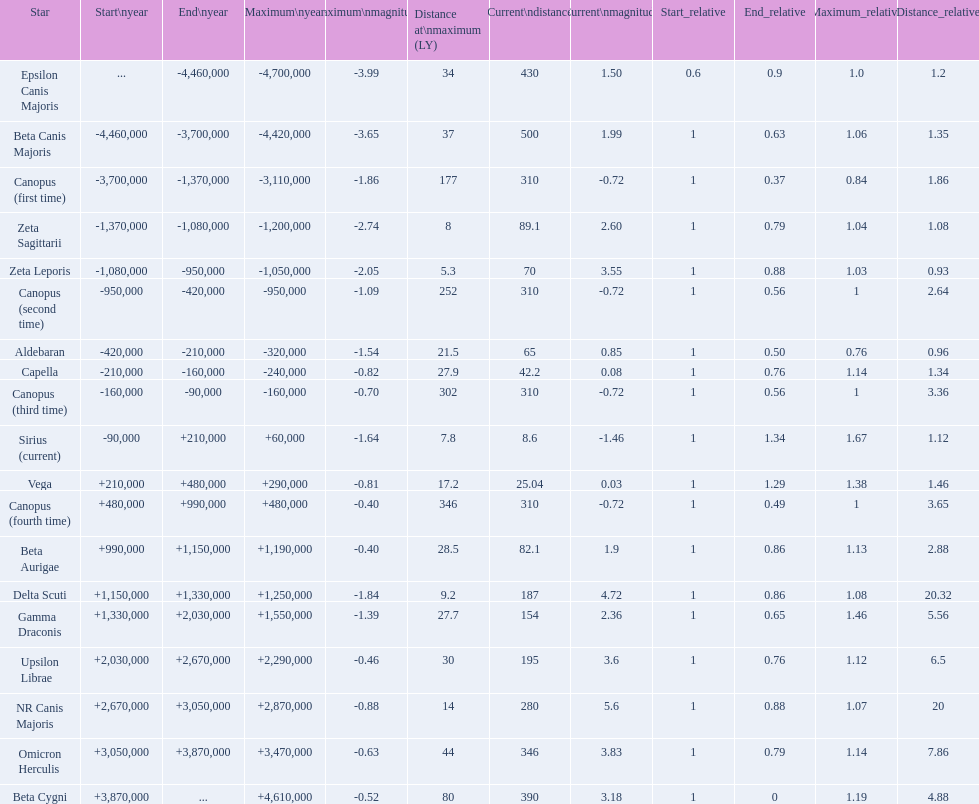How many stars have a magnitude greater than zero? 14. 